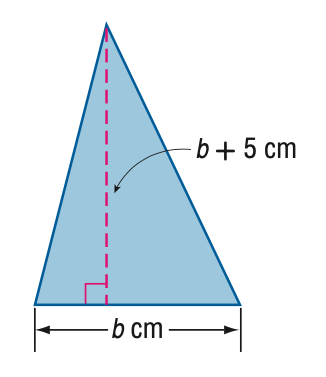Answer the mathemtical geometry problem and directly provide the correct option letter.
Question: The height of a triangle is 5 centimeters more than its base. The area of the triangle is 52 square centimeters. Find the height.
Choices: A: 10.1 B: 13 C: 14.9 D: 18 B 